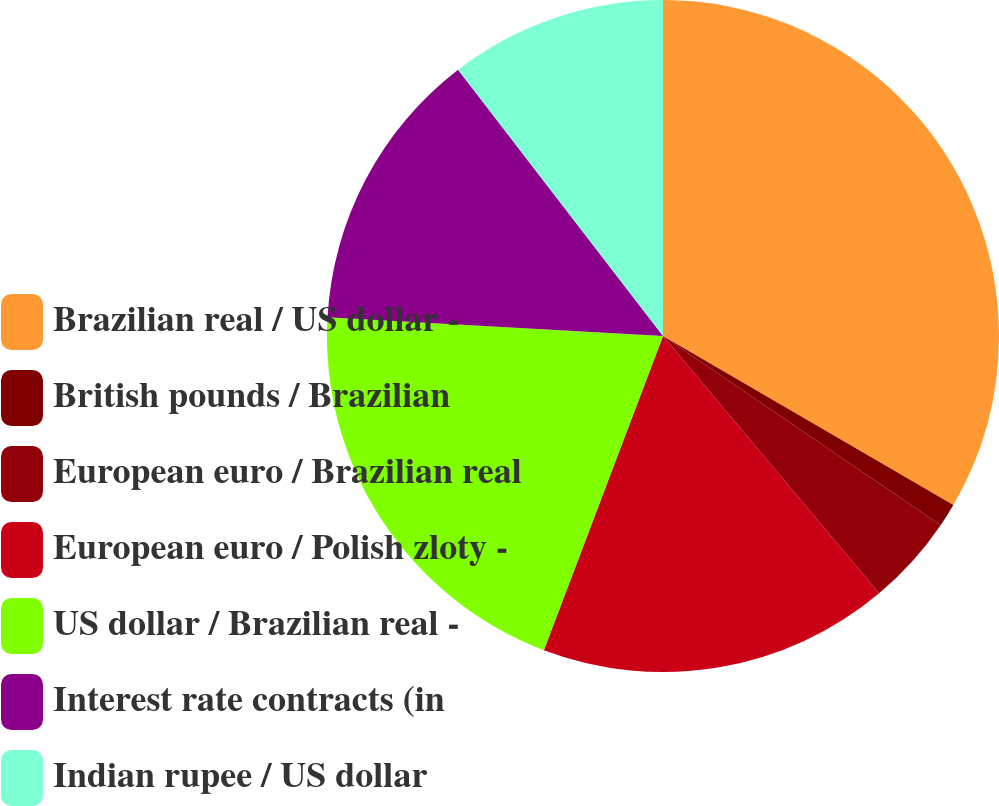Convert chart to OTSL. <chart><loc_0><loc_0><loc_500><loc_500><pie_chart><fcel>Brazilian real / US dollar -<fcel>British pounds / Brazilian<fcel>European euro / Brazilian real<fcel>European euro / Polish zloty -<fcel>US dollar / Brazilian real -<fcel>Interest rate contracts (in<fcel>Indian rupee / US dollar<nl><fcel>33.39%<fcel>1.13%<fcel>4.36%<fcel>16.89%<fcel>20.12%<fcel>13.67%<fcel>10.44%<nl></chart> 